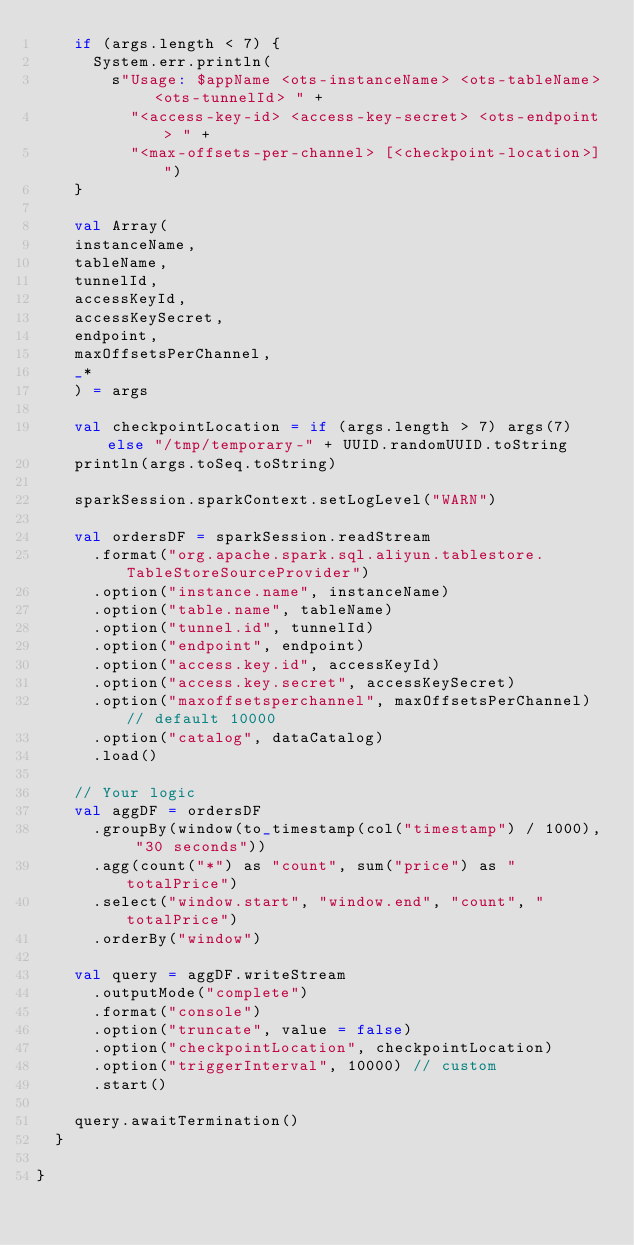<code> <loc_0><loc_0><loc_500><loc_500><_Scala_>    if (args.length < 7) {
      System.err.println(
        s"Usage: $appName <ots-instanceName> <ots-tableName> <ots-tunnelId> " +
          "<access-key-id> <access-key-secret> <ots-endpoint> " +
          "<max-offsets-per-channel> [<checkpoint-location>]")
    }

    val Array(
    instanceName,
    tableName,
    tunnelId,
    accessKeyId,
    accessKeySecret,
    endpoint,
    maxOffsetsPerChannel,
    _*
    ) = args

    val checkpointLocation = if (args.length > 7) args(7) else "/tmp/temporary-" + UUID.randomUUID.toString
    println(args.toSeq.toString)

    sparkSession.sparkContext.setLogLevel("WARN")

    val ordersDF = sparkSession.readStream
      .format("org.apache.spark.sql.aliyun.tablestore.TableStoreSourceProvider")
      .option("instance.name", instanceName)
      .option("table.name", tableName)
      .option("tunnel.id", tunnelId)
      .option("endpoint", endpoint)
      .option("access.key.id", accessKeyId)
      .option("access.key.secret", accessKeySecret)
      .option("maxoffsetsperchannel", maxOffsetsPerChannel) // default 10000
      .option("catalog", dataCatalog)
      .load()

    // Your logic
    val aggDF = ordersDF
      .groupBy(window(to_timestamp(col("timestamp") / 1000), "30 seconds"))
      .agg(count("*") as "count", sum("price") as "totalPrice")
      .select("window.start", "window.end", "count", "totalPrice")
      .orderBy("window")

    val query = aggDF.writeStream
      .outputMode("complete")
      .format("console")
      .option("truncate", value = false)
      .option("checkpointLocation", checkpointLocation)
      .option("triggerInterval", 10000) // custom
      .start()

    query.awaitTermination()
  }

}
</code> 